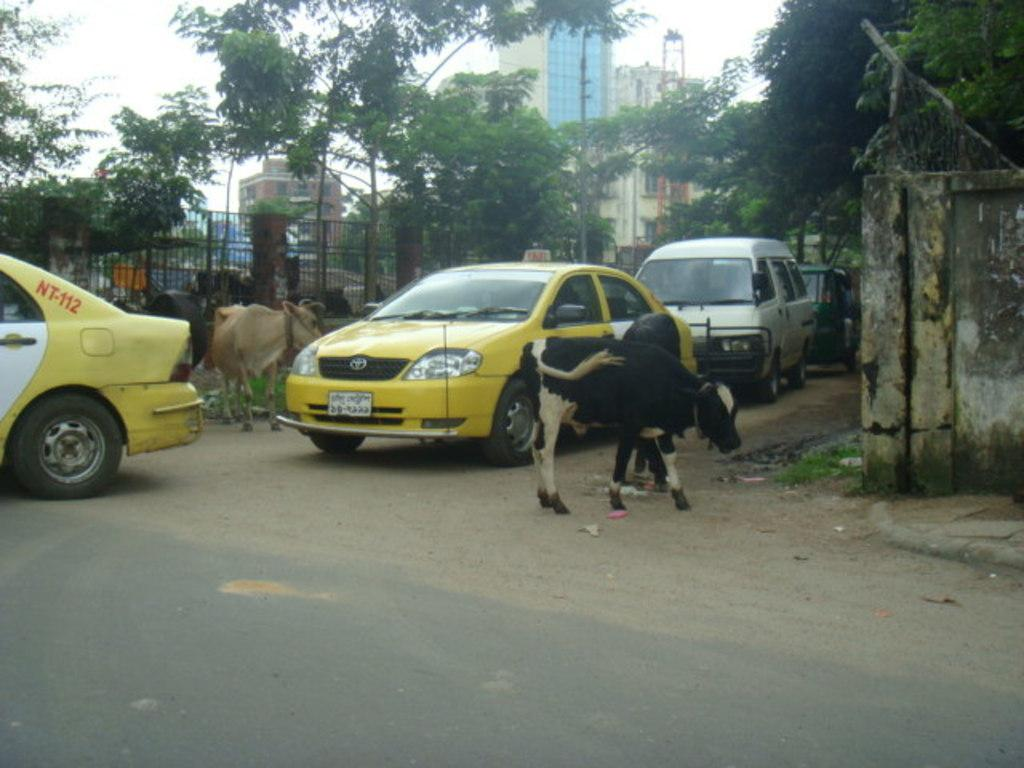<image>
Offer a succinct explanation of the picture presented. A cow is in the road by a yellow car that says Taxi on top. 